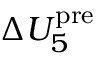<formula> <loc_0><loc_0><loc_500><loc_500>\Delta U _ { 5 } ^ { p r e }</formula> 